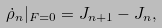Convert formula to latex. <formula><loc_0><loc_0><loc_500><loc_500>\dot { \rho } _ { n } | _ { F = 0 } = J _ { n + 1 } - J _ { n } ,</formula> 